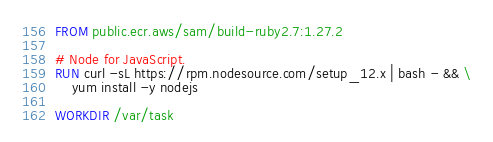Convert code to text. <code><loc_0><loc_0><loc_500><loc_500><_Dockerfile_>FROM public.ecr.aws/sam/build-ruby2.7:1.27.2

# Node for JavaScript.
RUN curl -sL https://rpm.nodesource.com/setup_12.x | bash - && \
    yum install -y nodejs

WORKDIR /var/task
</code> 